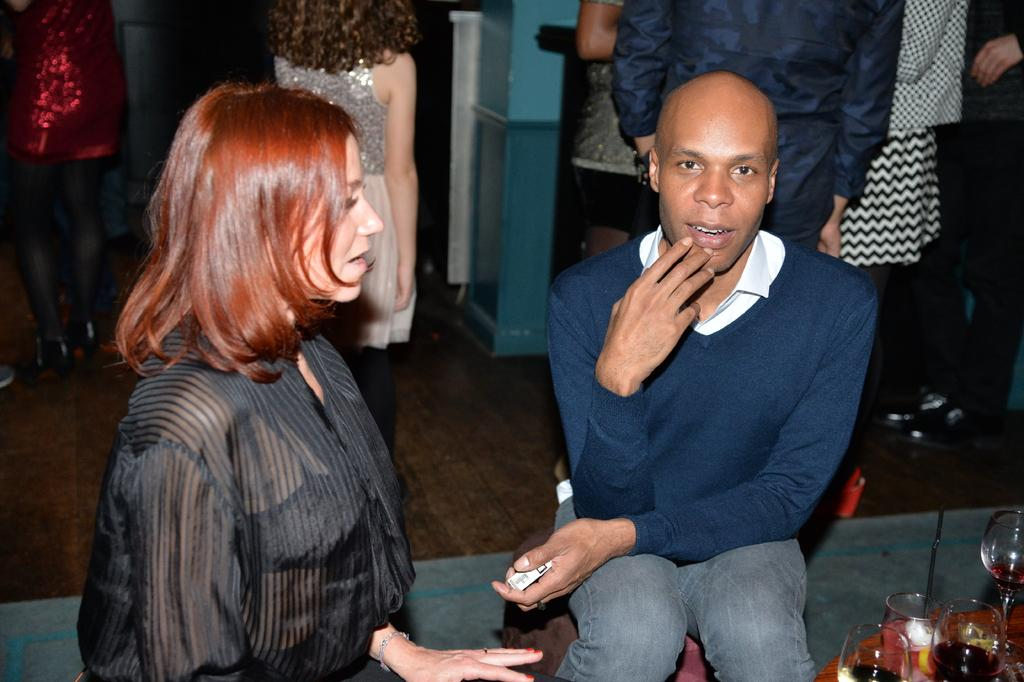How many people are sitting in the image? There are two persons sitting in the image. What objects can be seen on the table in the image? There are wine glasses on a table in the image. Can you describe the people in the background of the image? There are people standing in the background of the image. What type of skirt is the rat wearing in the image? There is no rat or skirt present in the image. 